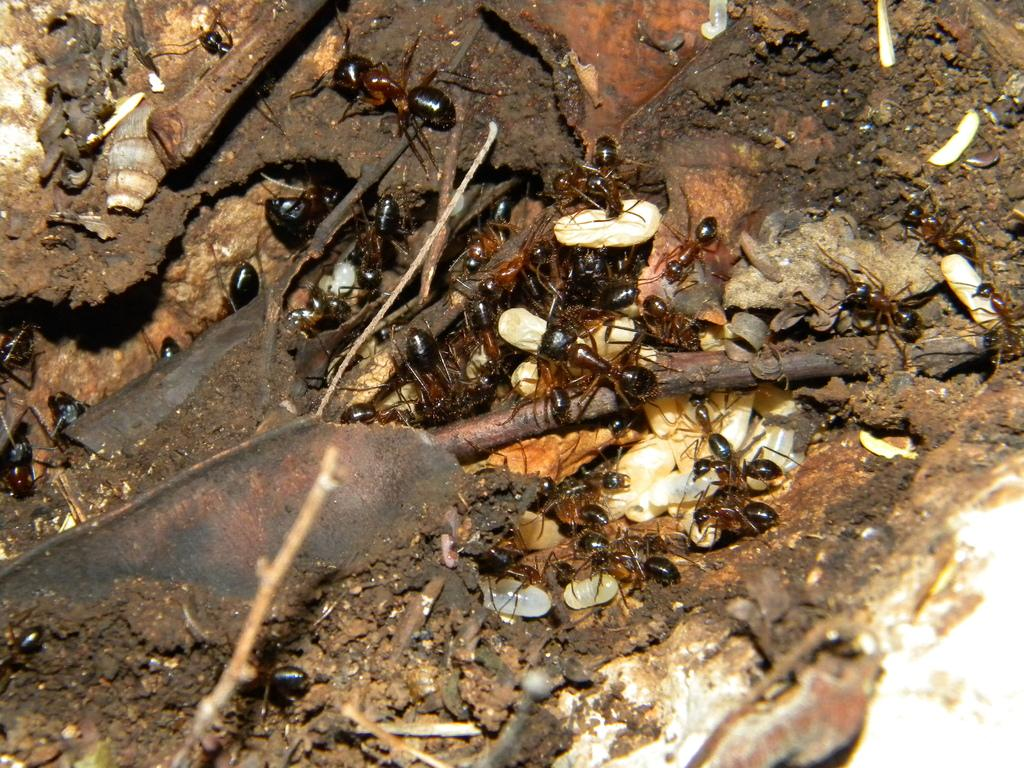What type of creatures are present in the image? There are ants in the image. What color are the ants? The ants are black in color. Where are the ants located in the image? The ants are on an object. What type of eye can be seen in the image? There is no eye present in the image; it features ants on an object. What type of whistle is being used by the ants in the image? There is no whistle present in the image; it features ants on an object. 